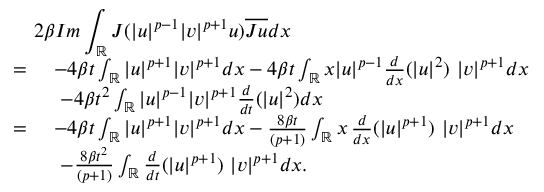Convert formula to latex. <formula><loc_0><loc_0><loc_500><loc_500>\begin{array} { r l } { { 2 \beta I m \int _ { \mathbb { R } } J ( | u | ^ { p - 1 } | v | ^ { p + 1 } u ) \overline { J u } d x } } \\ { = \ } & { - 4 \beta t \int _ { \mathbb { R } } | u | ^ { p + 1 } | v | ^ { p + 1 } d x - 4 \beta t \int _ { \mathbb { R } } x | u | ^ { p - 1 } \frac { d } { d x } ( | u | ^ { 2 } ) \ | v | ^ { p + 1 } d x } \\ & { \ - 4 \beta t ^ { 2 } \int _ { \mathbb { R } } | u | ^ { p - 1 } | v | ^ { p + 1 } \frac { d } { d t } ( | u | ^ { 2 } ) d x } \\ { = \ } & { - 4 \beta t \int _ { \mathbb { R } } | u | ^ { p + 1 } | v | ^ { p + 1 } d x - \frac { 8 \beta t } { ( p + 1 ) } \int _ { \mathbb { R } } x \, \frac { d } { d x } ( | u | ^ { p + 1 } ) \ | v | ^ { p + 1 } d x } \\ & { \ - \frac { 8 \beta t ^ { 2 } } { ( p + 1 ) } \int _ { \mathbb { R } } \frac { d } { d t } ( | u | ^ { p + 1 } ) \ | v | ^ { p + 1 } d x . } \end{array}</formula> 